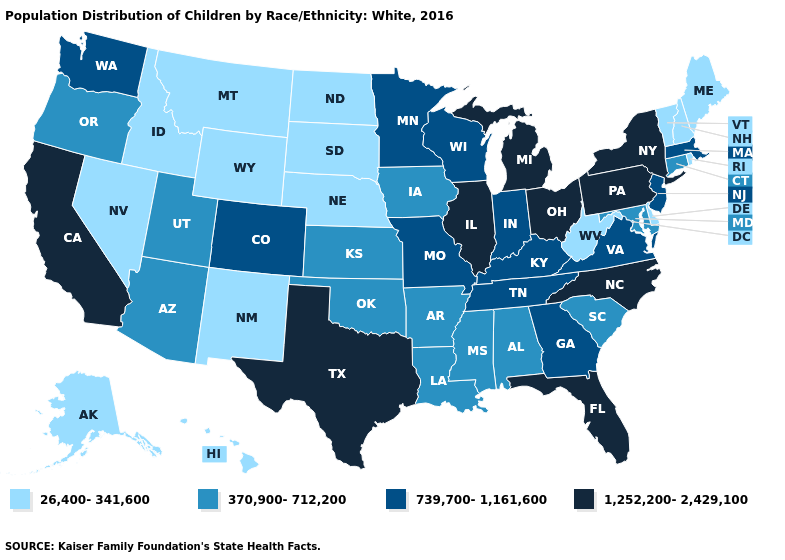Does Pennsylvania have a higher value than Texas?
Write a very short answer. No. Which states have the lowest value in the USA?
Concise answer only. Alaska, Delaware, Hawaii, Idaho, Maine, Montana, Nebraska, Nevada, New Hampshire, New Mexico, North Dakota, Rhode Island, South Dakota, Vermont, West Virginia, Wyoming. Which states hav the highest value in the MidWest?
Give a very brief answer. Illinois, Michigan, Ohio. What is the value of North Carolina?
Write a very short answer. 1,252,200-2,429,100. What is the value of Wyoming?
Quick response, please. 26,400-341,600. Does the map have missing data?
Answer briefly. No. Does Louisiana have a lower value than California?
Keep it brief. Yes. Which states have the lowest value in the South?
Quick response, please. Delaware, West Virginia. Does Minnesota have a higher value than Ohio?
Short answer required. No. How many symbols are there in the legend?
Quick response, please. 4. What is the value of New Jersey?
Answer briefly. 739,700-1,161,600. Does New Jersey have the lowest value in the Northeast?
Be succinct. No. What is the value of North Dakota?
Keep it brief. 26,400-341,600. Name the states that have a value in the range 1,252,200-2,429,100?
Give a very brief answer. California, Florida, Illinois, Michigan, New York, North Carolina, Ohio, Pennsylvania, Texas. 